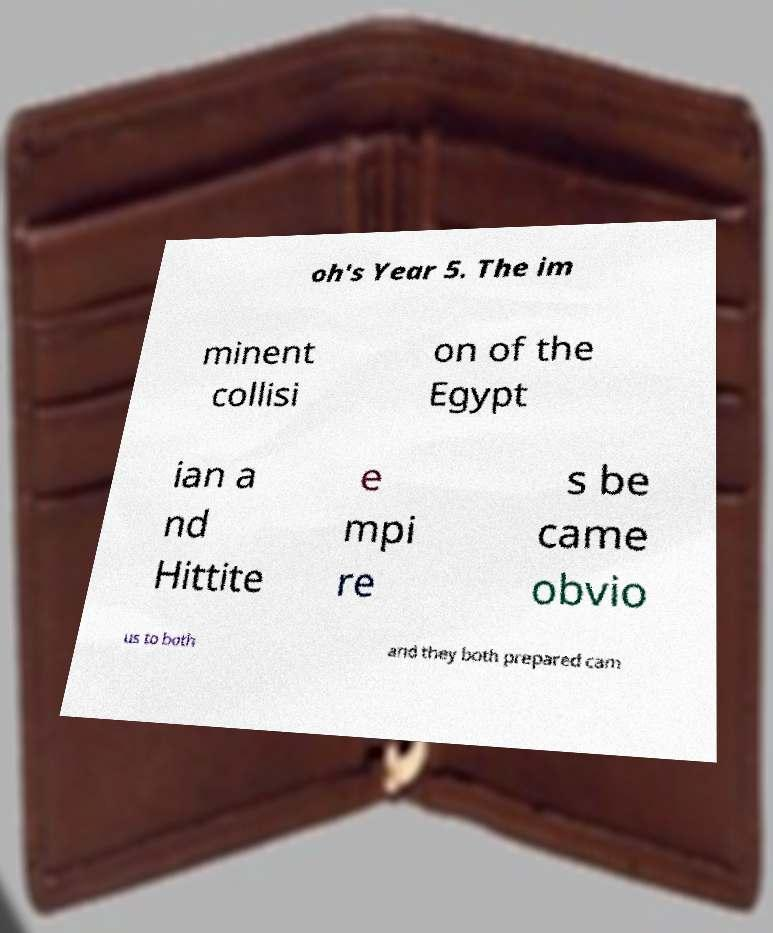There's text embedded in this image that I need extracted. Can you transcribe it verbatim? oh's Year 5. The im minent collisi on of the Egypt ian a nd Hittite e mpi re s be came obvio us to both and they both prepared cam 